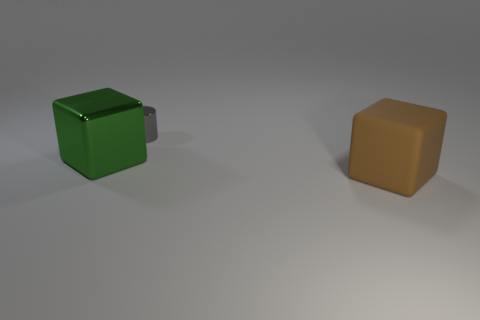The block that is the same material as the small thing is what color?
Ensure brevity in your answer.  Green. What material is the big brown cube?
Your answer should be very brief. Rubber. What is the shape of the large green metal object?
Provide a succinct answer. Cube. There is a block on the left side of the large object in front of the thing left of the tiny shiny cylinder; what is its material?
Provide a short and direct response. Metal. How many blue things are either shiny blocks or small cylinders?
Give a very brief answer. 0. There is a object in front of the block on the left side of the object behind the green shiny block; what size is it?
Ensure brevity in your answer.  Large. There is a green metallic object that is the same shape as the brown rubber thing; what is its size?
Give a very brief answer. Large. What number of large objects are either gray metallic objects or brown objects?
Your response must be concise. 1. Are the gray cylinder on the right side of the large green shiny thing and the big cube on the left side of the gray shiny thing made of the same material?
Offer a terse response. Yes. What material is the cube behind the brown object?
Give a very brief answer. Metal. 